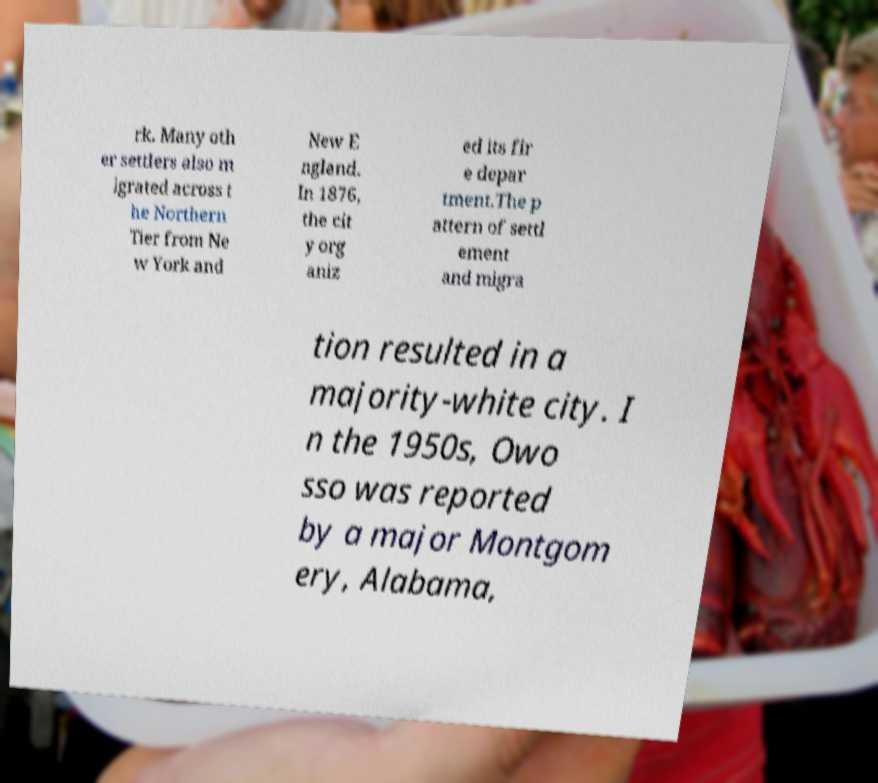Can you accurately transcribe the text from the provided image for me? rk. Many oth er settlers also m igrated across t he Northern Tier from Ne w York and New E ngland. In 1876, the cit y org aniz ed its fir e depar tment.The p attern of settl ement and migra tion resulted in a majority-white city. I n the 1950s, Owo sso was reported by a major Montgom ery, Alabama, 